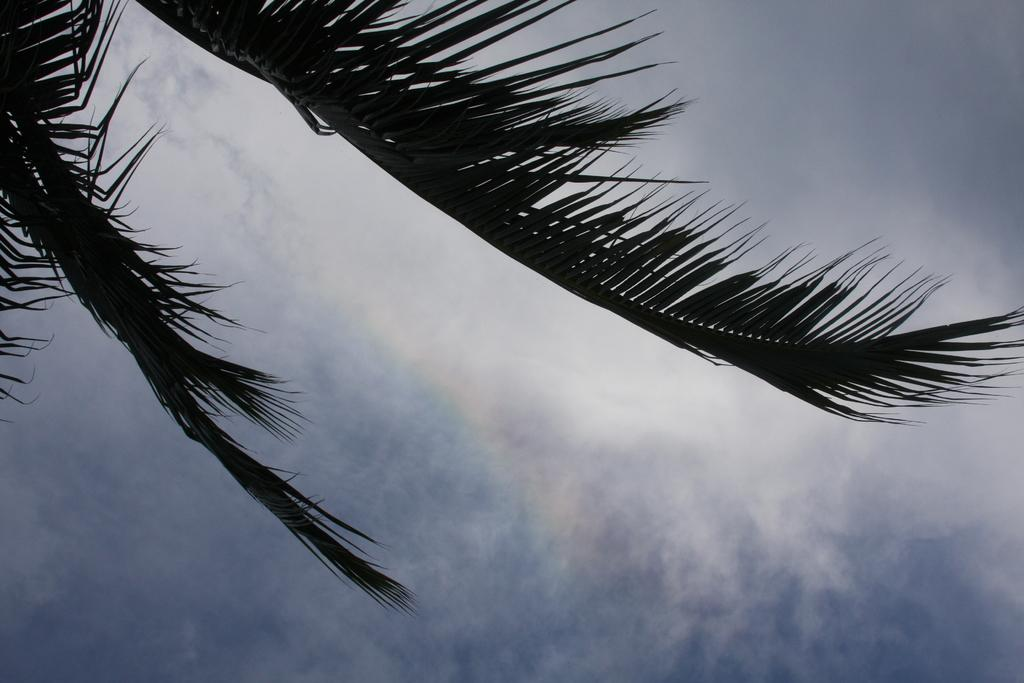What type of vegetation is in the foreground of the image? There are branches of a palm tree in the foreground of the image. What can be seen in the background of the image? The background of the image is the sky. What type of caption is written on the branches of the palm tree in the image? There is no caption written on the branches of the palm tree in the image. What type of fictional character can be seen interacting with the palm tree in the image? There are no fictional characters present in the image; it only features branches of a palm tree and the sky. 